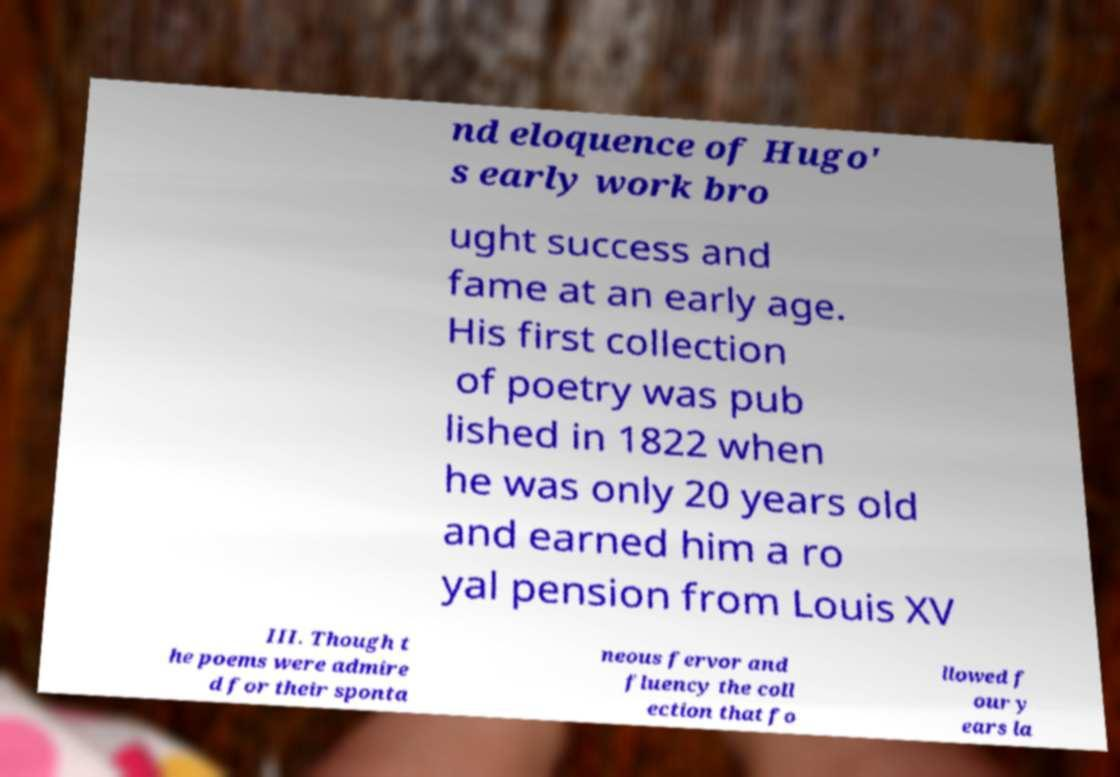I need the written content from this picture converted into text. Can you do that? nd eloquence of Hugo' s early work bro ught success and fame at an early age. His first collection of poetry was pub lished in 1822 when he was only 20 years old and earned him a ro yal pension from Louis XV III. Though t he poems were admire d for their sponta neous fervor and fluency the coll ection that fo llowed f our y ears la 